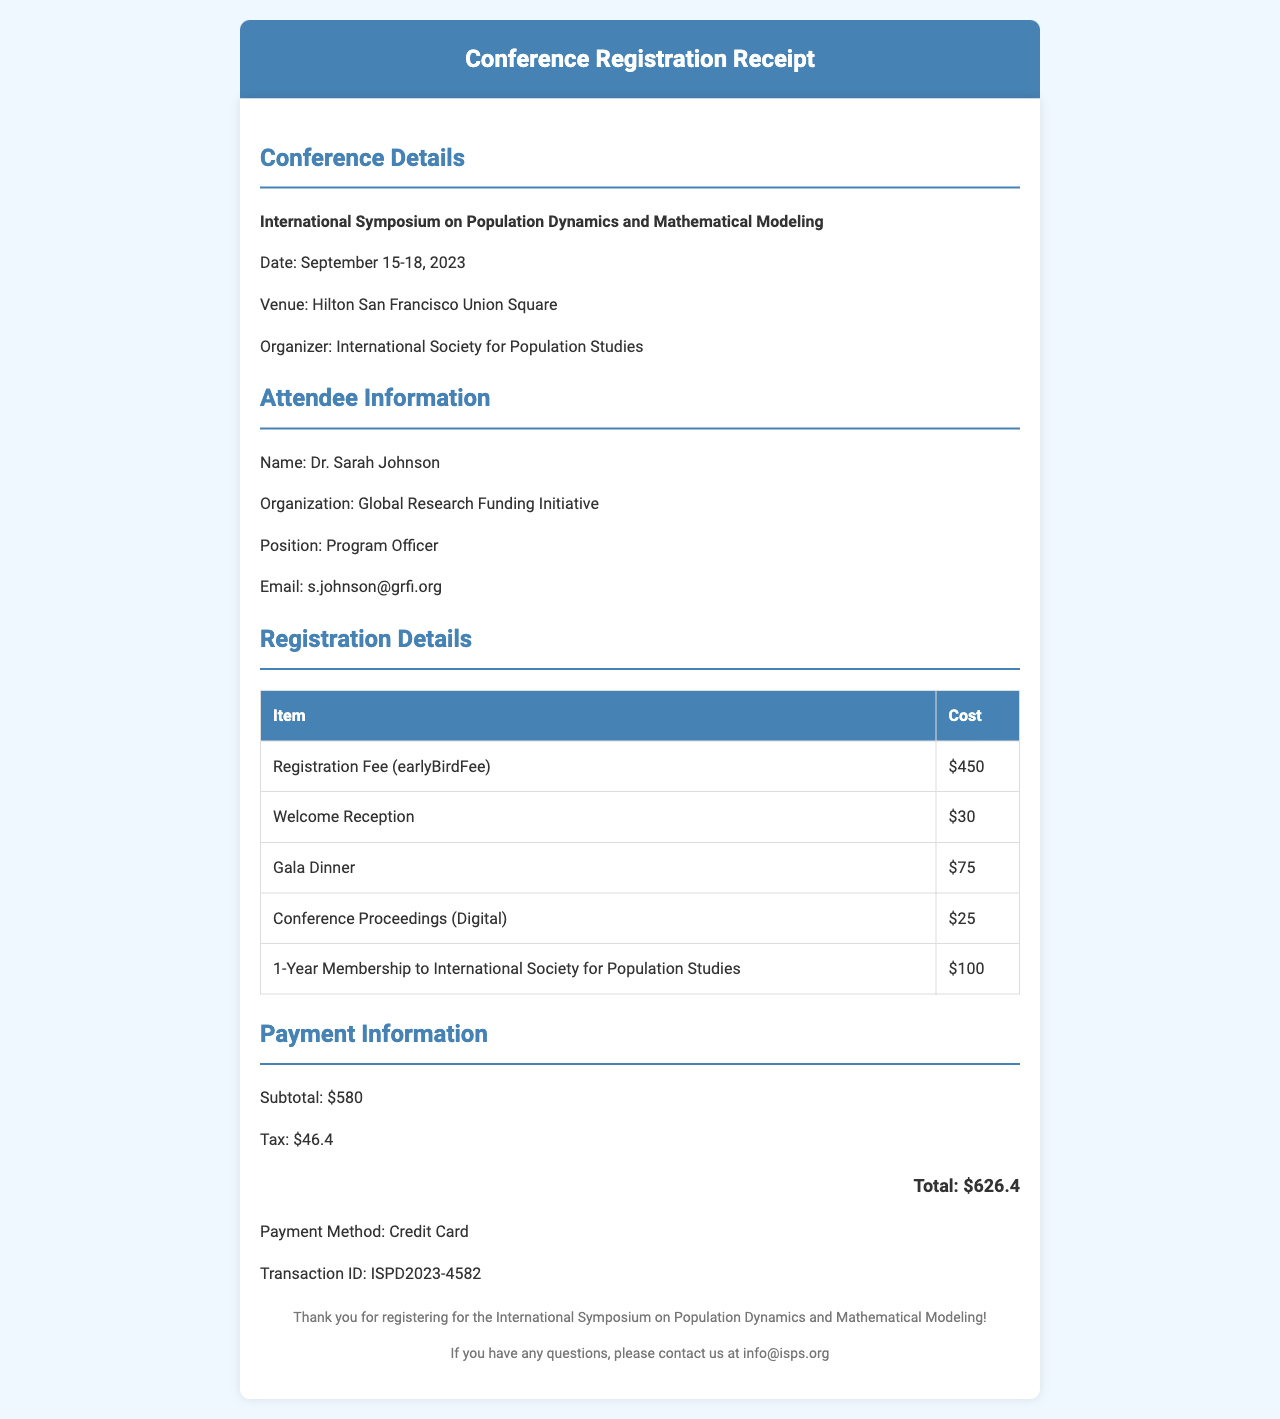What is the name of the conference? The name of the conference is stated in the conference details section of the document.
Answer: International Symposium on Population Dynamics and Mathematical Modeling What is the date of the gala dinner? The date of the gala dinner is mentioned in the networking events section.
Answer: September 17, 2023 Who is the speaker for the keynote session? The speaker for the keynote session is listed in the sessions section of the document.
Answer: Prof. David Smith, Oxford University What is the cost of the early bird registration fee? The cost for the early bird registration fee is mentioned in the registration fees section.
Answer: $450 What is the total amount to be paid? The total amount to be paid is included in payment information, which summarizes all costs.
Answer: $626.40 How many networking events are listed in the document? The number of networking events is calculated by counting the entries in the networking events section.
Answer: 2 What payment method was used for registration? The payment method is specified in the payment information section.
Answer: Credit Card What is included in the additional items? The additional items are listed separately and include items with their respective costs.
Answer: Conference Proceedings (Digital) and 1-Year Membership to International Society for Population Studies 